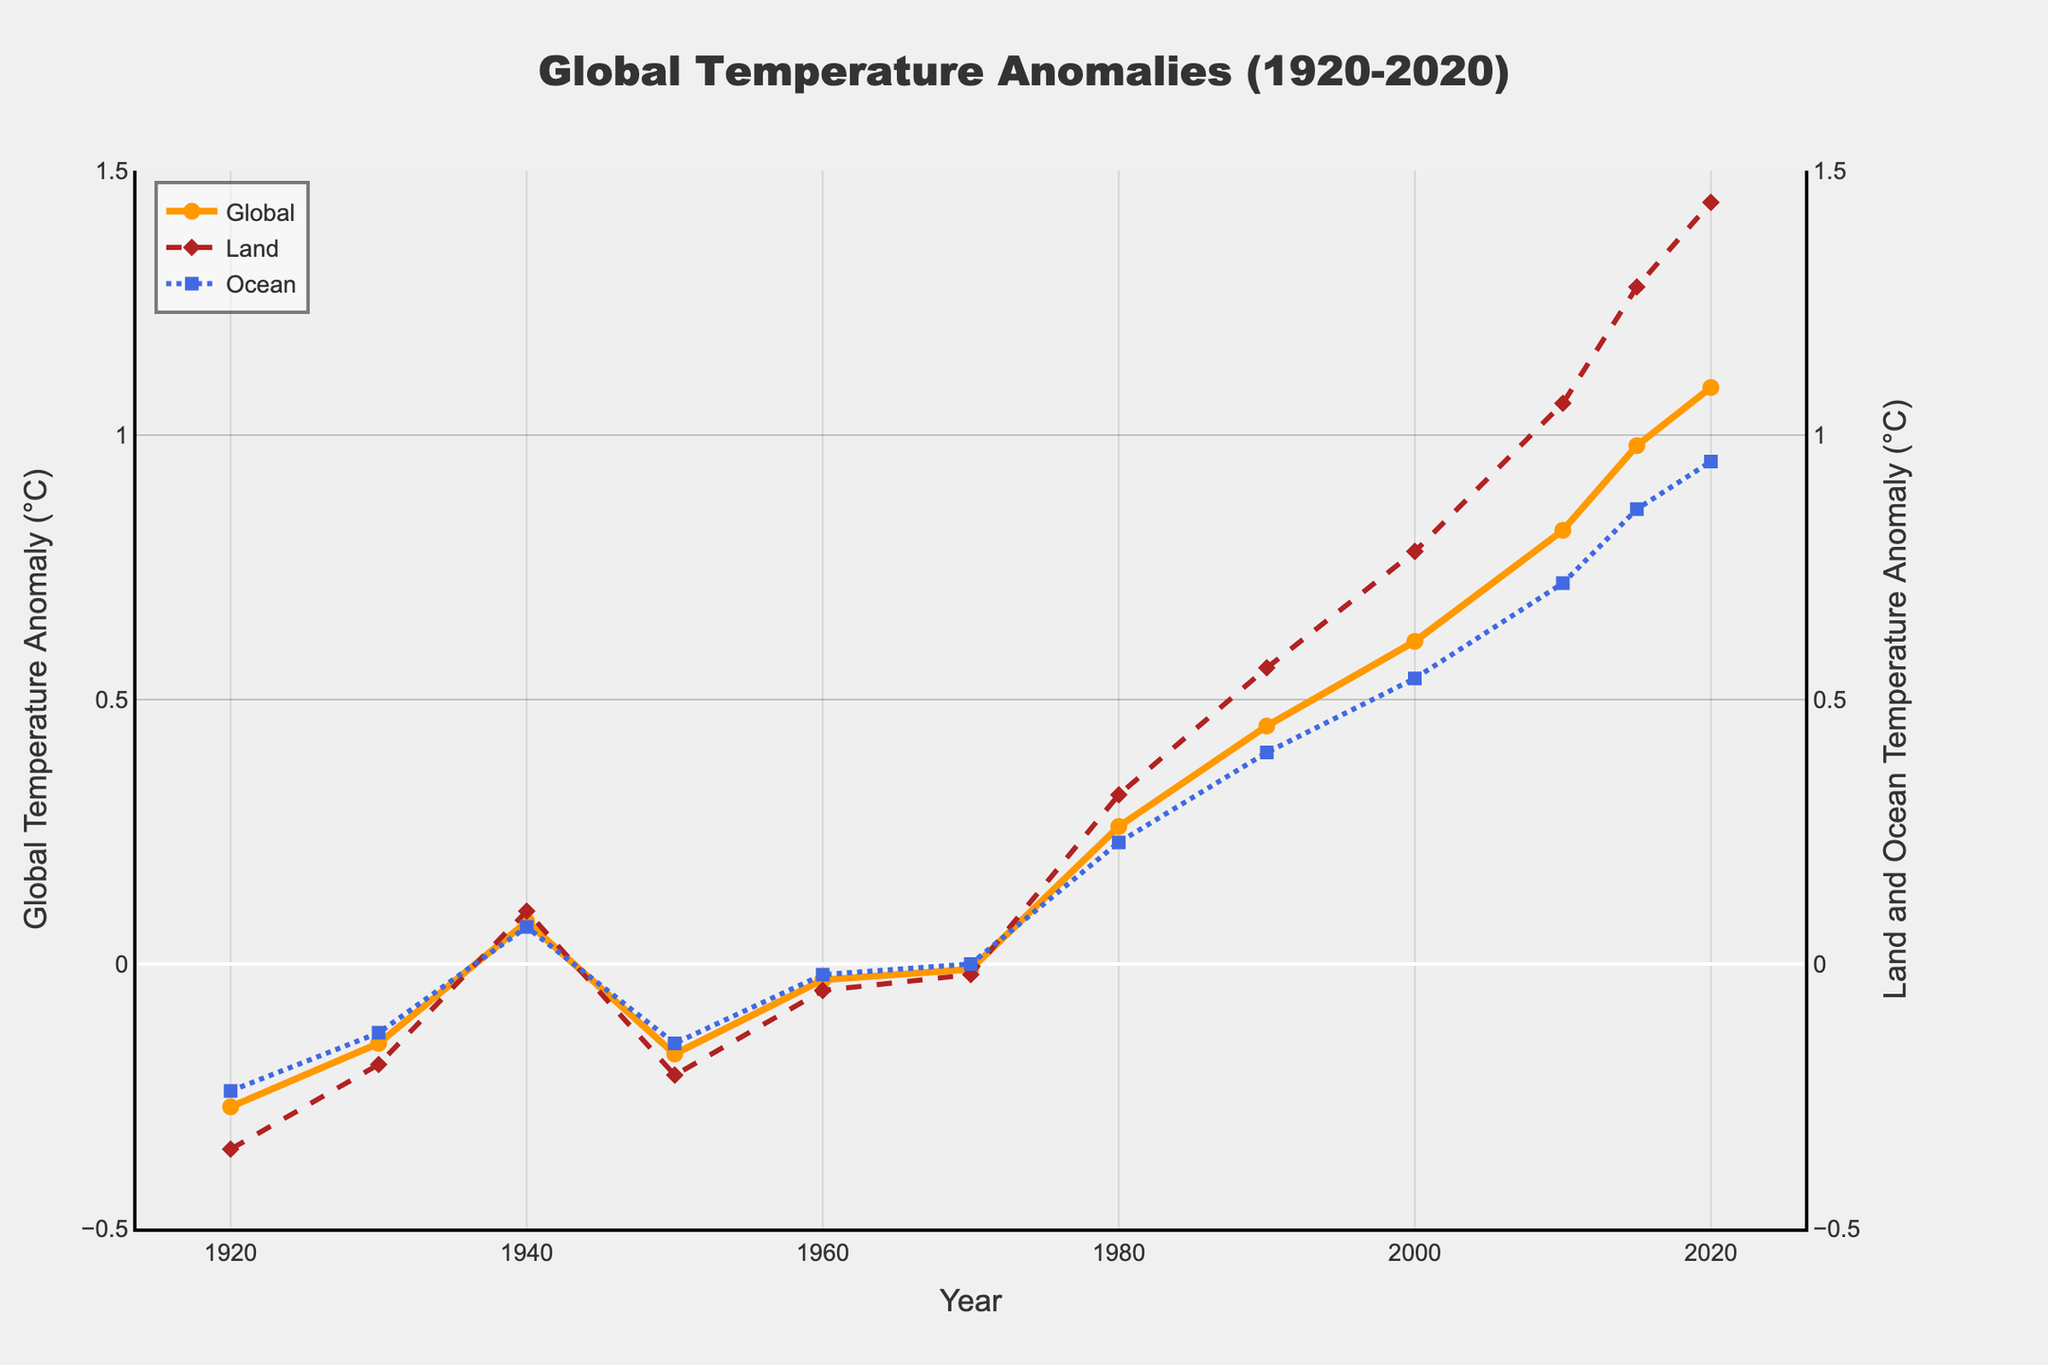What is the general trend of global temperature anomalies from 1920 to 2020? The global average temperature anomaly shows an increasing trend from 1920 to 2020, starting from approximately -0.27°C in 1920 and reaching about 1.09°C in 2020.
Answer: Increasing trend Which year exhibits the highest land temperature anomaly, and what is its value? The highest land temperature anomaly occurs in the year 2020, with a value of approximately 1.44°C.
Answer: 2020, 1.44°C How does the ocean temperature anomaly in 1940 compare to that in 1980? The ocean temperature anomaly in 1940 was approximately 0.07°C, while in 1980, it was about 0.23°C. Therefore, the ocean temperature anomaly in 1980 is higher than in 1940.
Answer: Higher In which year did the global average temperature anomaly first become positive? The global average temperature anomaly first became positive in the year 1940, with a value of approximately 0.08°C.
Answer: 1940 What is the difference between the land and ocean temperature anomalies in 2015? In 2015, the land temperature anomaly was approximately 1.28°C, and the ocean temperature anomaly was about 0.86°C. The difference is 1.28°C - 0.86°C = 0.42°C.
Answer: 0.42°C What is the average global average temperature anomaly for the years 1980, 1990, and 2000? The global average temperature anomalies for the years 1980, 1990, and 2000 are 0.26°C, 0.45°C, and 0.61°C, respectively. The average is (0.26 + 0.45 + 0.61) / 3 = 1.32 / 3 = 0.44°C.
Answer: 0.44°C Which temperature anomaly (land, ocean, or global) has the greatest increase from 1970 to 2020? From 1970 to 2020, the land temperature anomaly increased from approximately -0.02°C to 1.44°C. The ocean and global temperature anomalies increased from 0.00°C to 0.95°C and -0.01°C to 1.09°C, respectively. Therefore, the land temperature anomaly has the greatest increase.
Answer: Land What color represents the ocean temperature anomaly in the plot, and what is its visual pattern? The ocean temperature anomaly is represented by the color blue and has a dashed-dot line pattern with square markers.
Answer: Blue, dashed-dot 